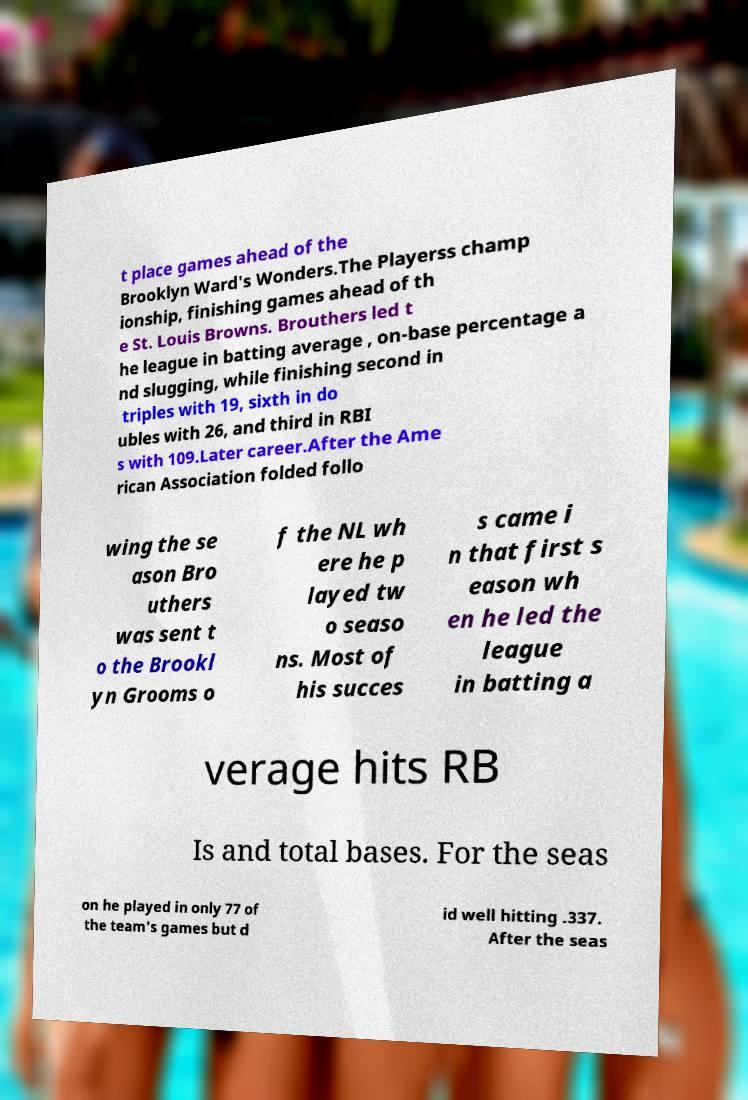There's text embedded in this image that I need extracted. Can you transcribe it verbatim? t place games ahead of the Brooklyn Ward's Wonders.The Playerss champ ionship, finishing games ahead of th e St. Louis Browns. Brouthers led t he league in batting average , on-base percentage a nd slugging, while finishing second in triples with 19, sixth in do ubles with 26, and third in RBI s with 109.Later career.After the Ame rican Association folded follo wing the se ason Bro uthers was sent t o the Brookl yn Grooms o f the NL wh ere he p layed tw o seaso ns. Most of his succes s came i n that first s eason wh en he led the league in batting a verage hits RB Is and total bases. For the seas on he played in only 77 of the team's games but d id well hitting .337. After the seas 